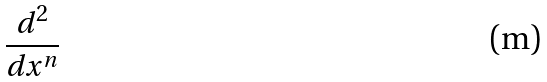Convert formula to latex. <formula><loc_0><loc_0><loc_500><loc_500>\frac { d ^ { 2 } } { d x ^ { n } }</formula> 